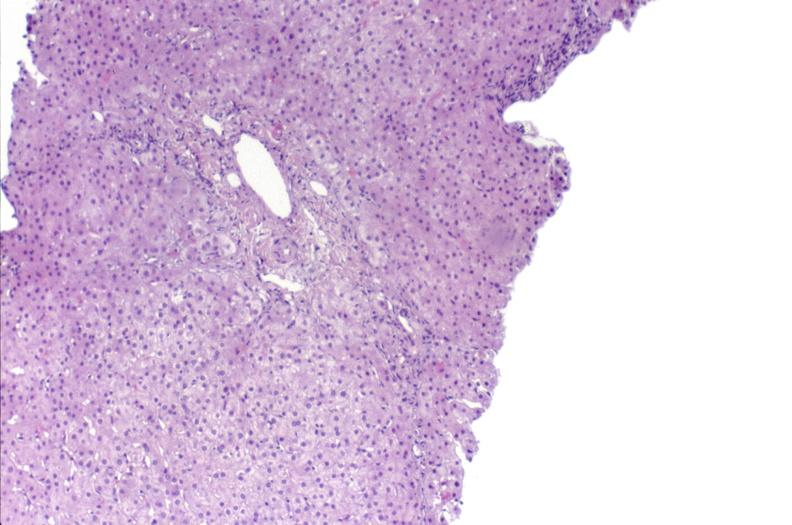does mucoepidermoid carcinoma show ductopenia?
Answer the question using a single word or phrase. No 